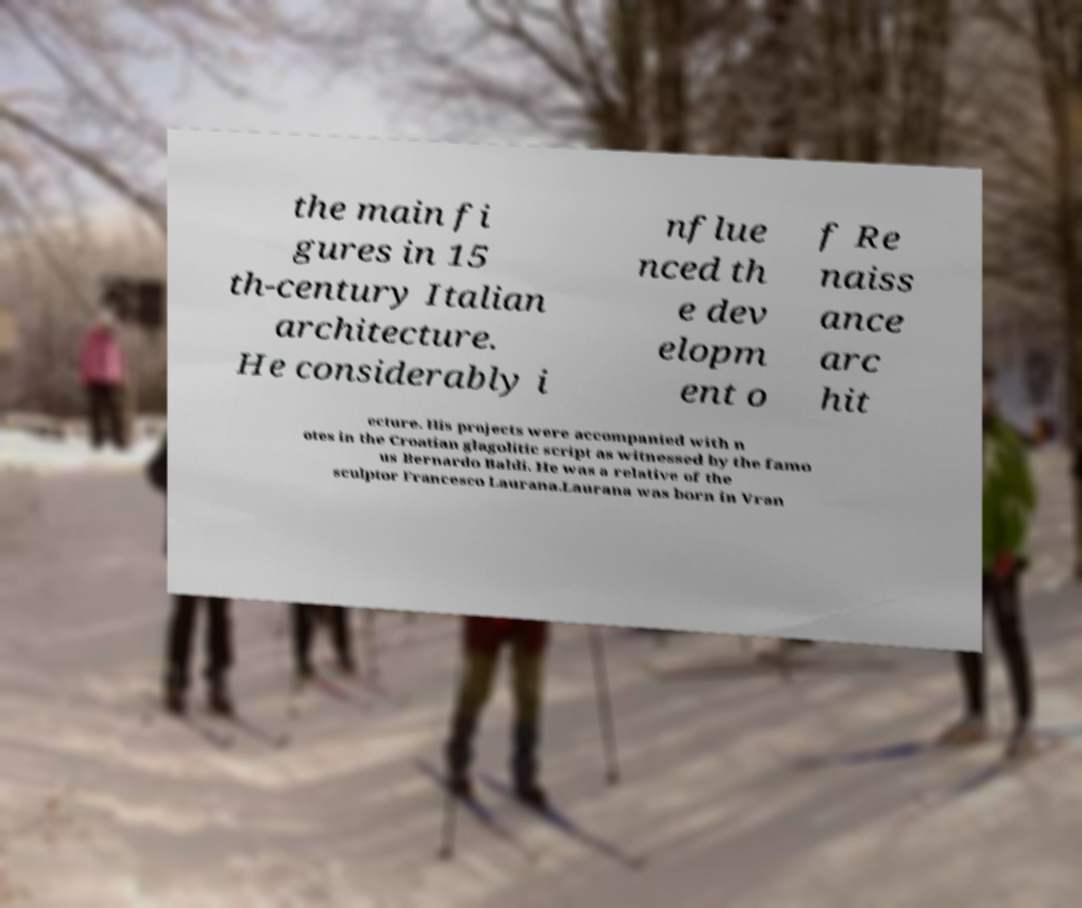Can you read and provide the text displayed in the image?This photo seems to have some interesting text. Can you extract and type it out for me? the main fi gures in 15 th-century Italian architecture. He considerably i nflue nced th e dev elopm ent o f Re naiss ance arc hit ecture. His projects were accompanied with n otes in the Croatian glagolitic script as witnessed by the famo us Bernardo Baldi. He was a relative of the sculptor Francesco Laurana.Laurana was born in Vran 